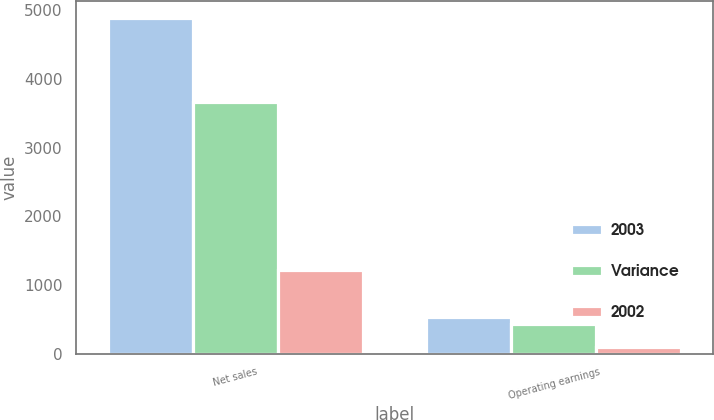<chart> <loc_0><loc_0><loc_500><loc_500><stacked_bar_chart><ecel><fcel>Net sales<fcel>Operating earnings<nl><fcel>2003<fcel>4889<fcel>536<nl><fcel>Variance<fcel>3669<fcel>435<nl><fcel>2002<fcel>1220<fcel>101<nl></chart> 